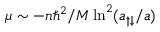Convert formula to latex. <formula><loc_0><loc_0><loc_500><loc_500>\mu \sim - n \hbar { ^ } { 2 } / M \ln ^ { 2 } ( a _ { \uparrow \downarrow } / a )</formula> 